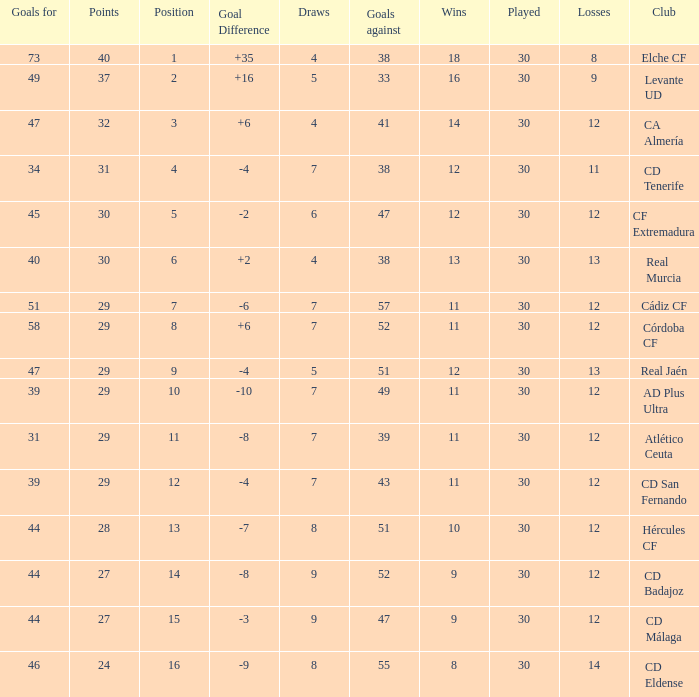What is the lowest amount of draws with less than 12 wins and less than 30 played? None. 